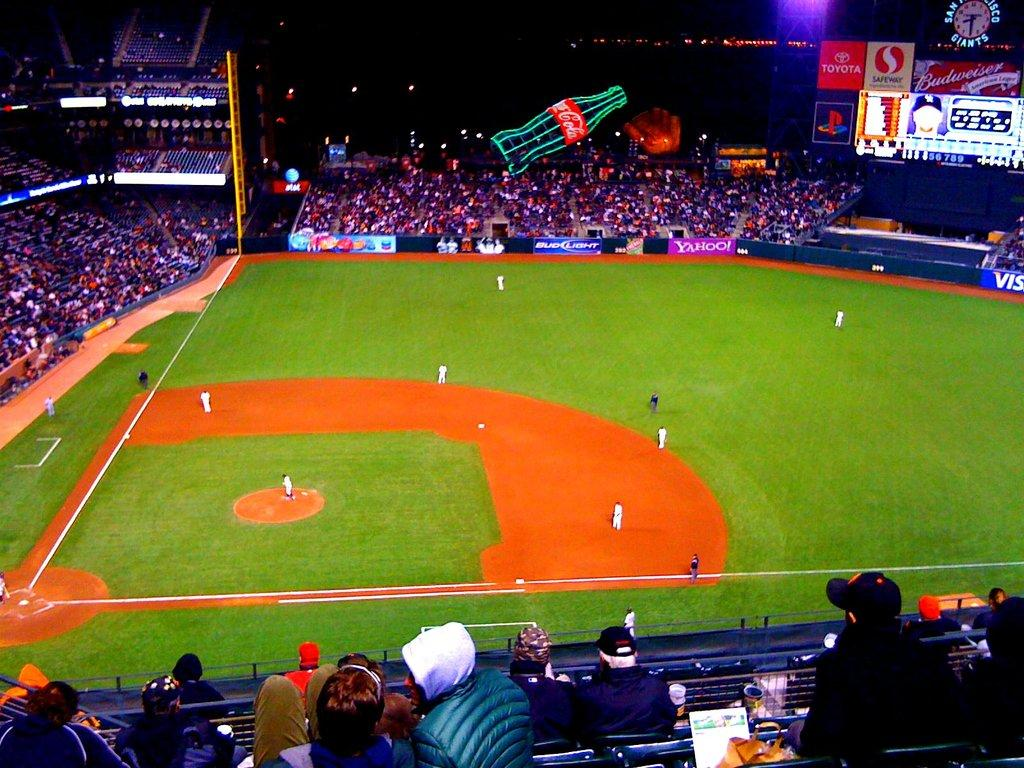What type of structure is the main subject of the image? There is a stadium in the image. What are the people in the image doing? People are sitting around the ground in the stadium. Are there any decorations or signs in the stadium? Yes, there are posters in the stadium. What feature is present to indicate the time? A clock is present in the stadium. How is the stadium illuminated? There is lighting in the stadium. What type of joke is being told by the toad in the image? There is no toad present in the image, and therefore no joke being told. What type of beef is being served in the stadium? There is no mention of food, specifically beef, being served in the image. 